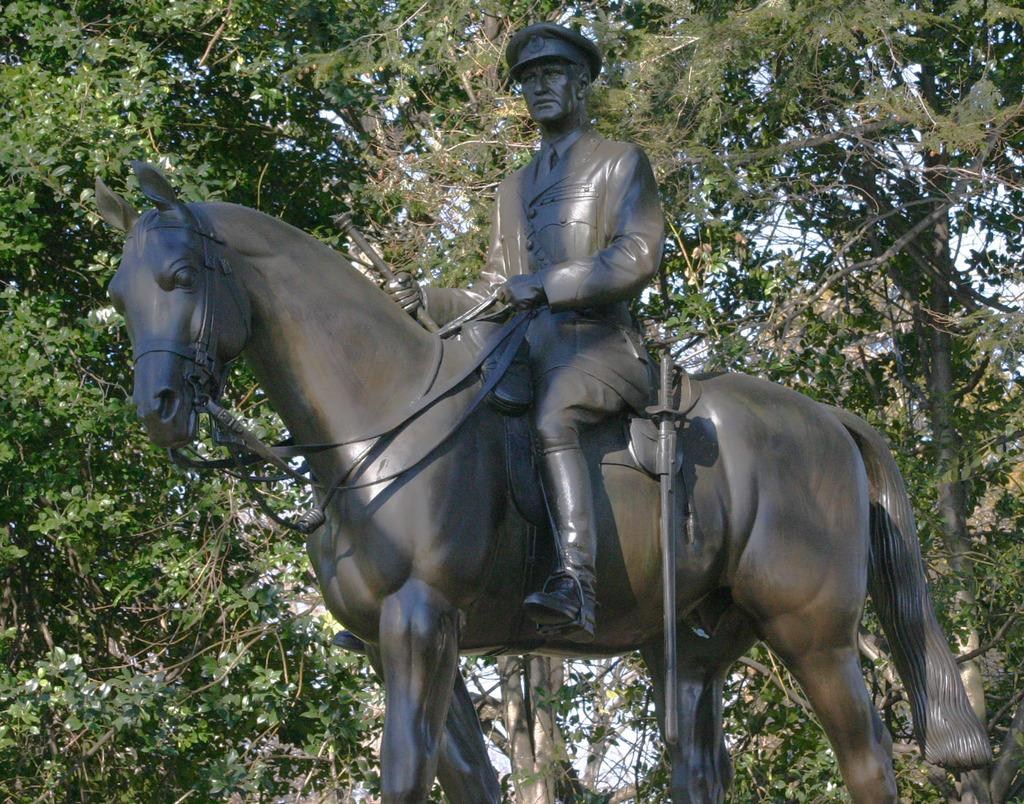What is the main subject of the image? There is a statue in the image. What is the statue depicting? The statue depicts a man sitting on a horse. What can be seen in the background of the image? There are trees in the background of the image. Can you tell me how many times the queen sneezes in the image? There is no queen present in the image, and therefore no sneezing can be observed. What type of tent is set up near the statue in the image? There is no tent present in the image; it only features a statue and trees in the background. 